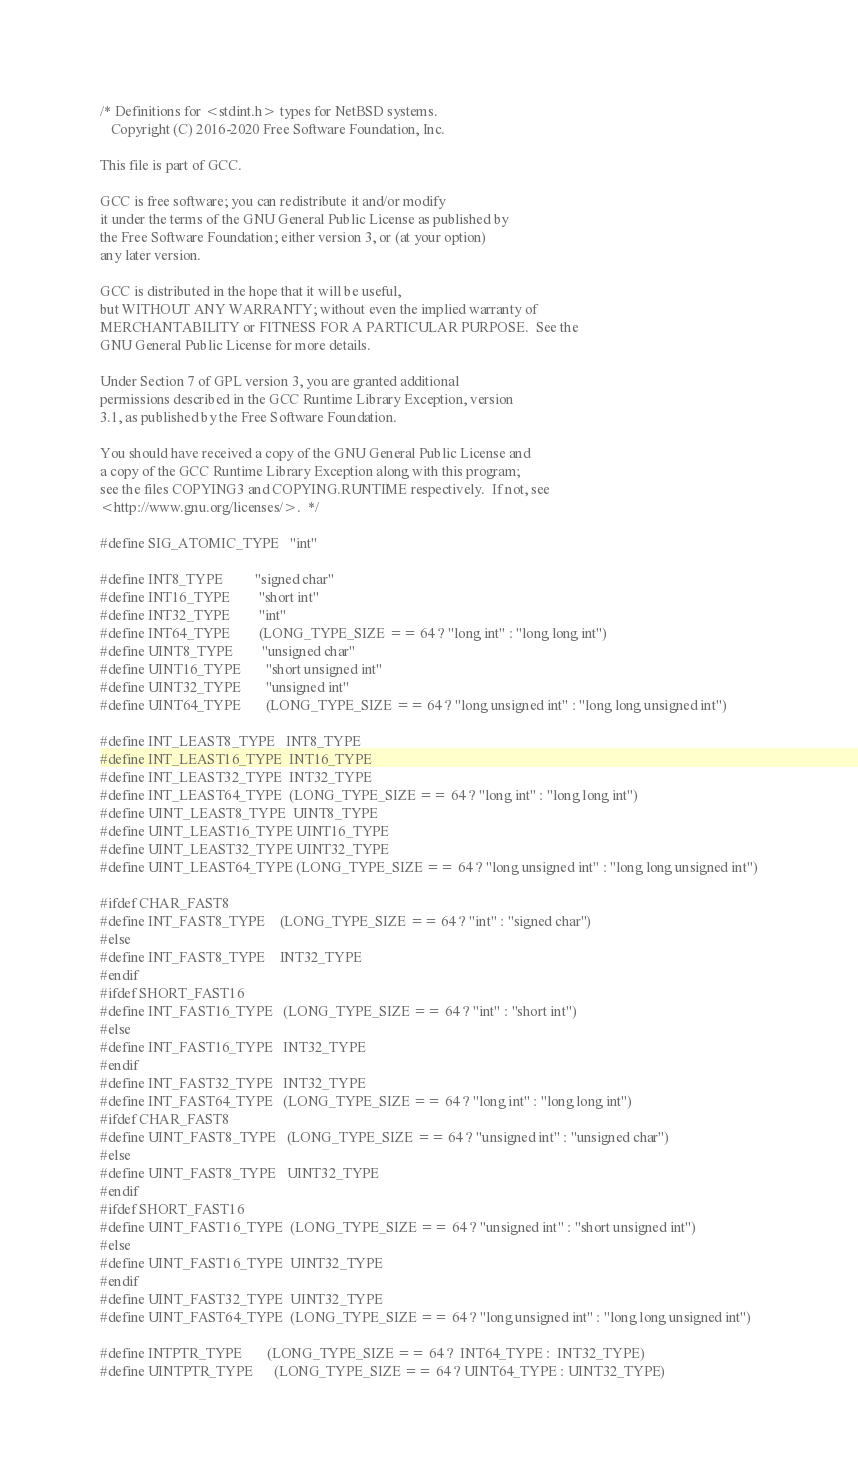Convert code to text. <code><loc_0><loc_0><loc_500><loc_500><_C_>/* Definitions for <stdint.h> types for NetBSD systems.
   Copyright (C) 2016-2020 Free Software Foundation, Inc.

This file is part of GCC.

GCC is free software; you can redistribute it and/or modify
it under the terms of the GNU General Public License as published by
the Free Software Foundation; either version 3, or (at your option)
any later version.

GCC is distributed in the hope that it will be useful,
but WITHOUT ANY WARRANTY; without even the implied warranty of
MERCHANTABILITY or FITNESS FOR A PARTICULAR PURPOSE.  See the
GNU General Public License for more details.

Under Section 7 of GPL version 3, you are granted additional
permissions described in the GCC Runtime Library Exception, version
3.1, as published by the Free Software Foundation.

You should have received a copy of the GNU General Public License and
a copy of the GCC Runtime Library Exception along with this program;
see the files COPYING3 and COPYING.RUNTIME respectively.  If not, see
<http://www.gnu.org/licenses/>.  */

#define SIG_ATOMIC_TYPE   "int"

#define INT8_TYPE         "signed char"
#define INT16_TYPE        "short int"
#define INT32_TYPE        "int"
#define INT64_TYPE        (LONG_TYPE_SIZE == 64 ? "long int" : "long long int")
#define UINT8_TYPE        "unsigned char"
#define UINT16_TYPE       "short unsigned int"
#define UINT32_TYPE       "unsigned int"
#define UINT64_TYPE       (LONG_TYPE_SIZE == 64 ? "long unsigned int" : "long long unsigned int")

#define INT_LEAST8_TYPE   INT8_TYPE
#define INT_LEAST16_TYPE  INT16_TYPE
#define INT_LEAST32_TYPE  INT32_TYPE
#define INT_LEAST64_TYPE  (LONG_TYPE_SIZE == 64 ? "long int" : "long long int")
#define UINT_LEAST8_TYPE  UINT8_TYPE
#define UINT_LEAST16_TYPE UINT16_TYPE
#define UINT_LEAST32_TYPE UINT32_TYPE
#define UINT_LEAST64_TYPE (LONG_TYPE_SIZE == 64 ? "long unsigned int" : "long long unsigned int")

#ifdef CHAR_FAST8
#define INT_FAST8_TYPE    (LONG_TYPE_SIZE == 64 ? "int" : "signed char")
#else
#define INT_FAST8_TYPE    INT32_TYPE
#endif
#ifdef SHORT_FAST16
#define INT_FAST16_TYPE   (LONG_TYPE_SIZE == 64 ? "int" : "short int")
#else
#define INT_FAST16_TYPE   INT32_TYPE
#endif
#define INT_FAST32_TYPE   INT32_TYPE
#define INT_FAST64_TYPE   (LONG_TYPE_SIZE == 64 ? "long int" : "long long int")
#ifdef CHAR_FAST8
#define UINT_FAST8_TYPE   (LONG_TYPE_SIZE == 64 ? "unsigned int" : "unsigned char")
#else
#define UINT_FAST8_TYPE   UINT32_TYPE
#endif
#ifdef SHORT_FAST16
#define UINT_FAST16_TYPE  (LONG_TYPE_SIZE == 64 ? "unsigned int" : "short unsigned int")
#else
#define UINT_FAST16_TYPE  UINT32_TYPE
#endif
#define UINT_FAST32_TYPE  UINT32_TYPE
#define UINT_FAST64_TYPE  (LONG_TYPE_SIZE == 64 ? "long unsigned int" : "long long unsigned int")

#define INTPTR_TYPE       (LONG_TYPE_SIZE == 64 ?  INT64_TYPE :  INT32_TYPE)
#define UINTPTR_TYPE      (LONG_TYPE_SIZE == 64 ? UINT64_TYPE : UINT32_TYPE)
</code> 